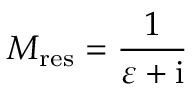Convert formula to latex. <formula><loc_0><loc_0><loc_500><loc_500>M _ { r e s } = \frac { 1 } { \varepsilon + { i } }</formula> 